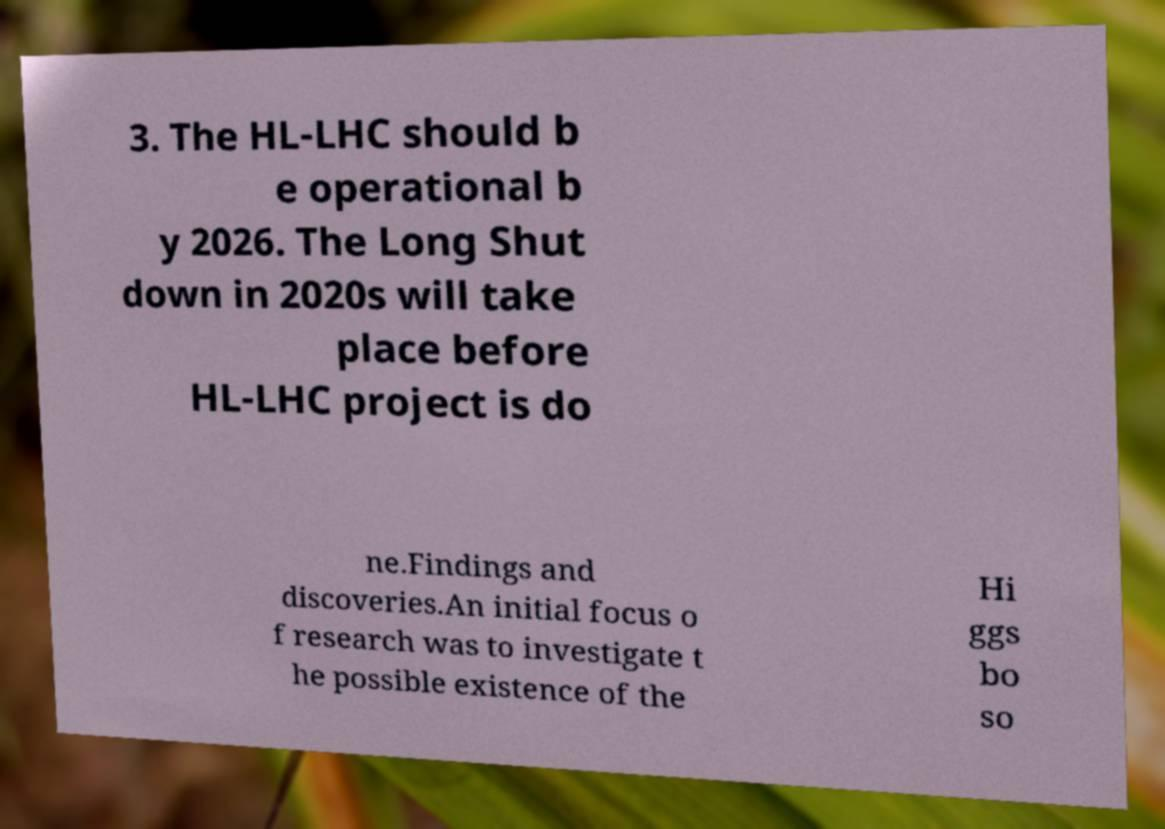Could you extract and type out the text from this image? 3. The HL-LHC should b e operational b y 2026. The Long Shut down in 2020s will take place before HL-LHC project is do ne.Findings and discoveries.An initial focus o f research was to investigate t he possible existence of the Hi ggs bo so 